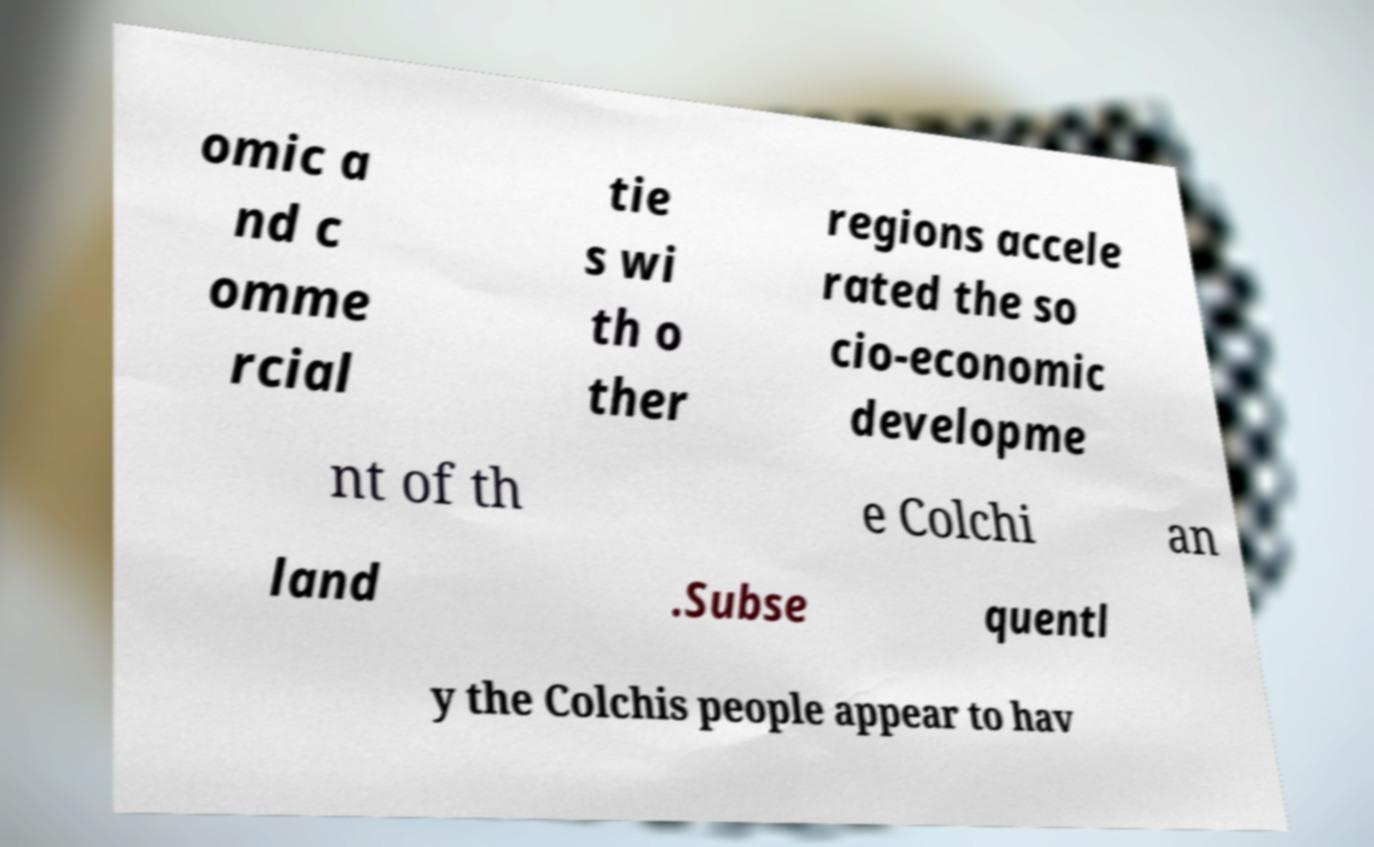Please identify and transcribe the text found in this image. omic a nd c omme rcial tie s wi th o ther regions accele rated the so cio-economic developme nt of th e Colchi an land .Subse quentl y the Colchis people appear to hav 